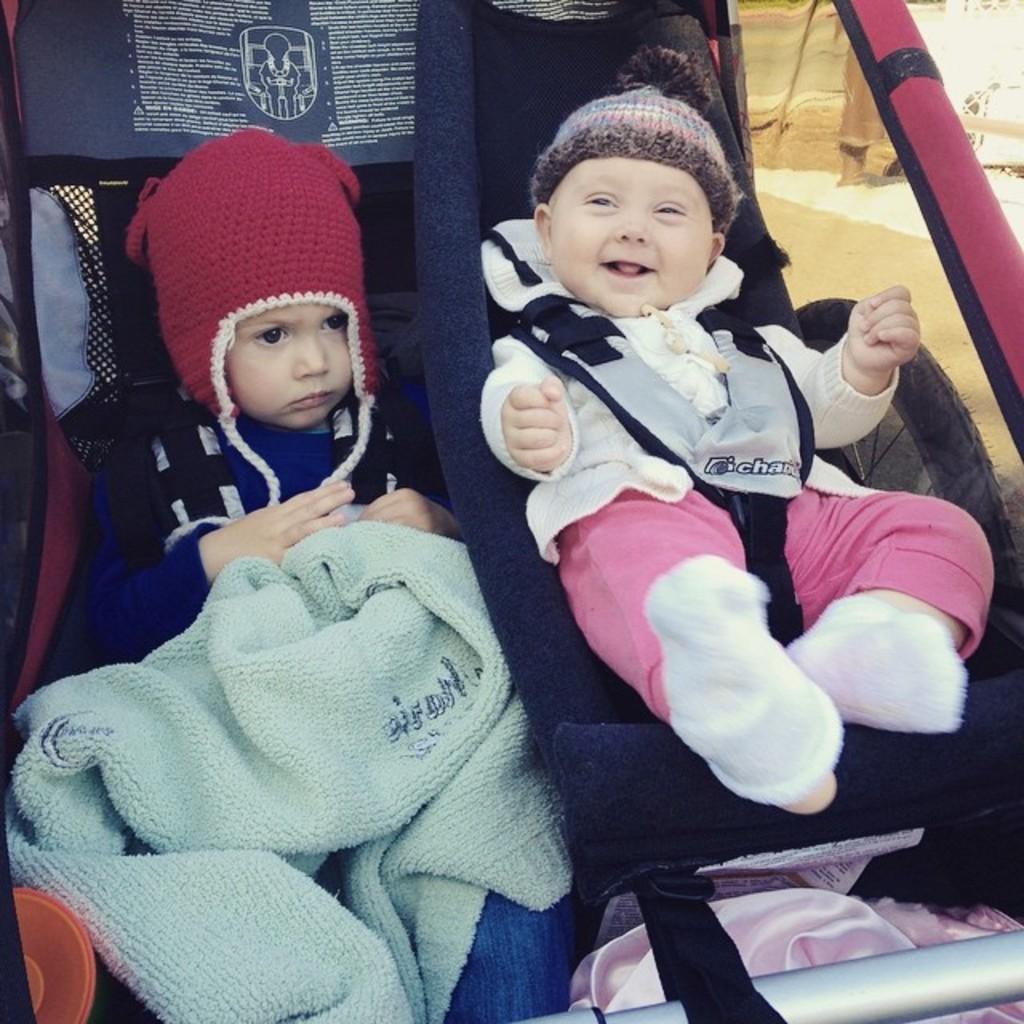In one or two sentences, can you explain what this image depicts? In this image we can see two babies wearing a dress and caps are in a baby carrier. 